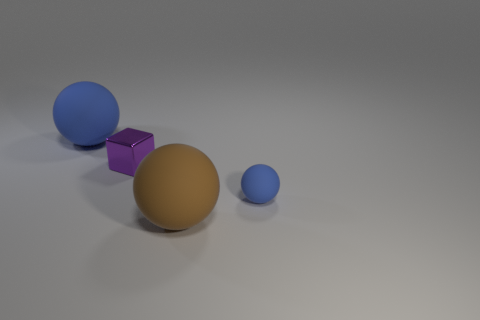Are there any tiny purple cubes behind the large blue matte ball?
Ensure brevity in your answer.  No. The big thing behind the blue matte sphere that is right of the brown ball is what color?
Ensure brevity in your answer.  Blue. Are there fewer tiny red blocks than objects?
Give a very brief answer. Yes. How many other blue objects are the same shape as the big blue object?
Offer a very short reply. 1. What is the color of the matte object that is the same size as the metallic object?
Offer a very short reply. Blue. Are there an equal number of tiny cubes in front of the small purple metal block and matte things in front of the big brown rubber object?
Ensure brevity in your answer.  Yes. Is there another metallic thing that has the same size as the purple object?
Provide a succinct answer. No. How big is the purple thing?
Make the answer very short. Small. Are there an equal number of tiny purple metal objects that are to the left of the small matte object and red cubes?
Keep it short and to the point. No. How many other things are there of the same color as the tiny sphere?
Give a very brief answer. 1. 